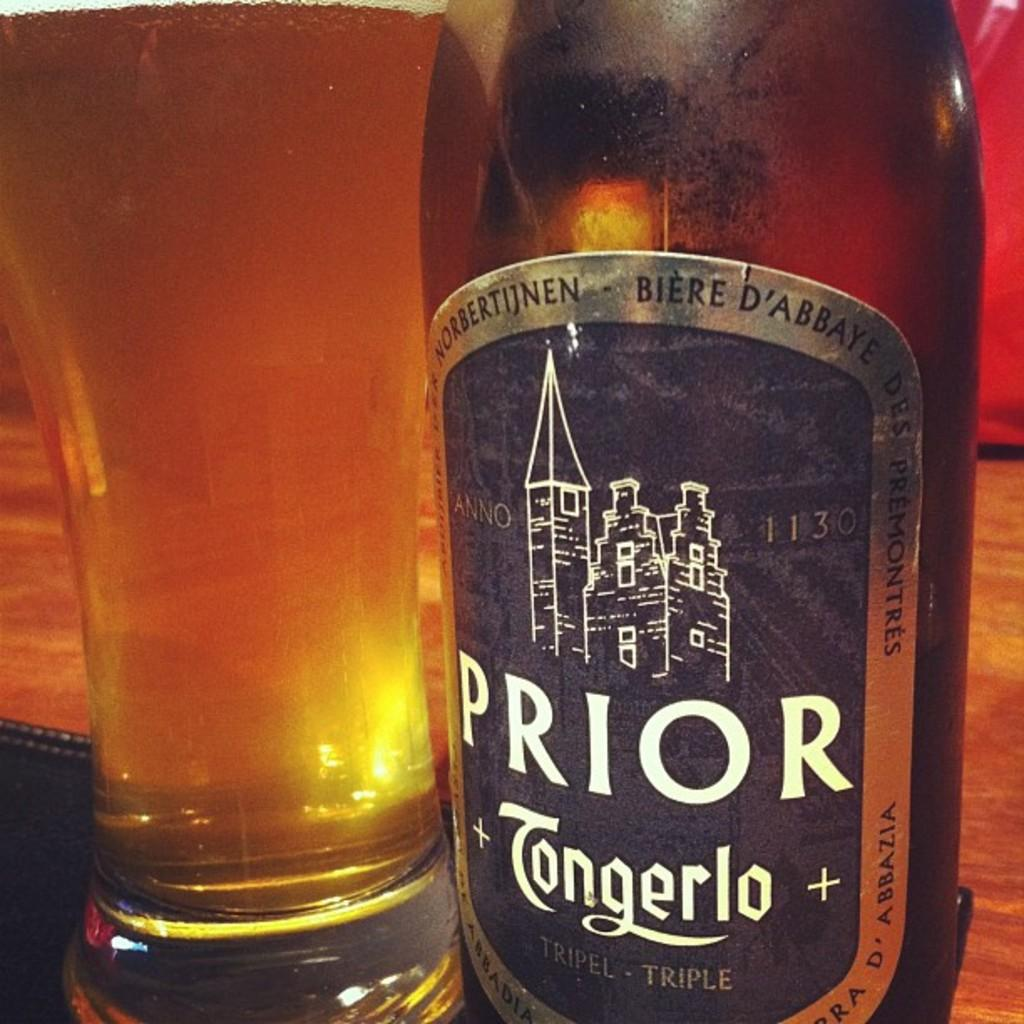<image>
Present a compact description of the photo's key features. A bottle of Prior is next to a full glass of beer. 